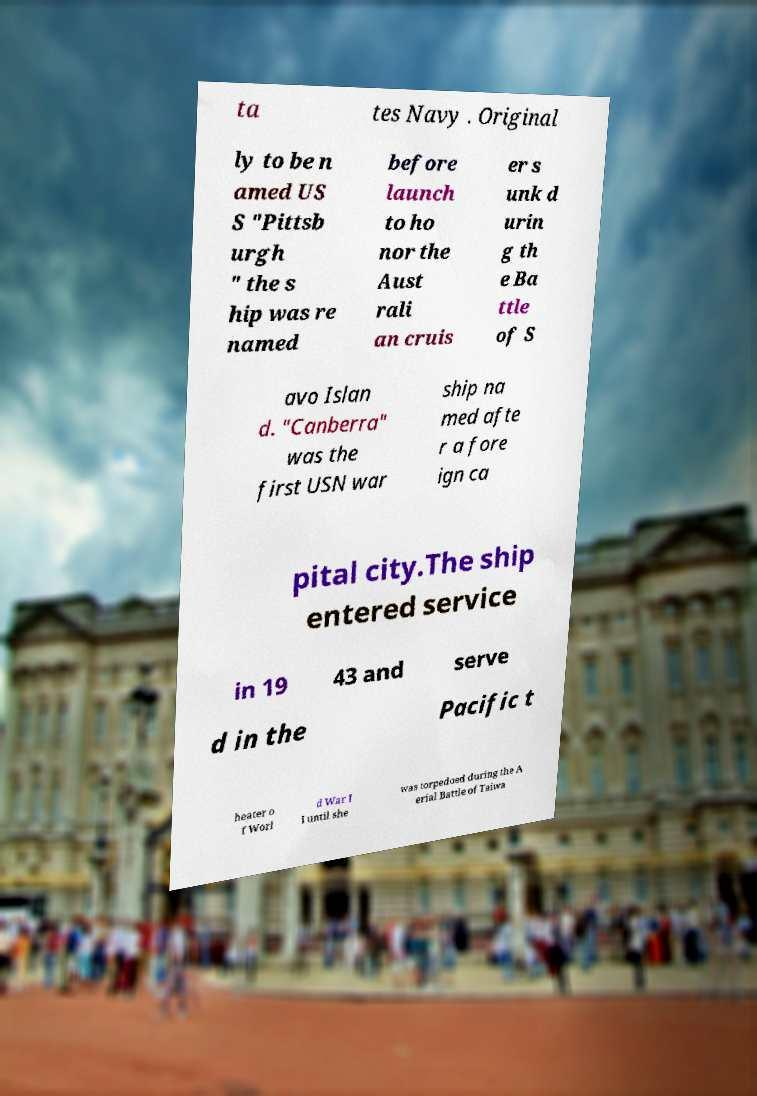Could you extract and type out the text from this image? ta tes Navy . Original ly to be n amed US S "Pittsb urgh " the s hip was re named before launch to ho nor the Aust rali an cruis er s unk d urin g th e Ba ttle of S avo Islan d. "Canberra" was the first USN war ship na med afte r a fore ign ca pital city.The ship entered service in 19 43 and serve d in the Pacific t heater o f Worl d War I I until she was torpedoed during the A erial Battle of Taiwa 